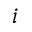Convert formula to latex. <formula><loc_0><loc_0><loc_500><loc_500>i</formula> 